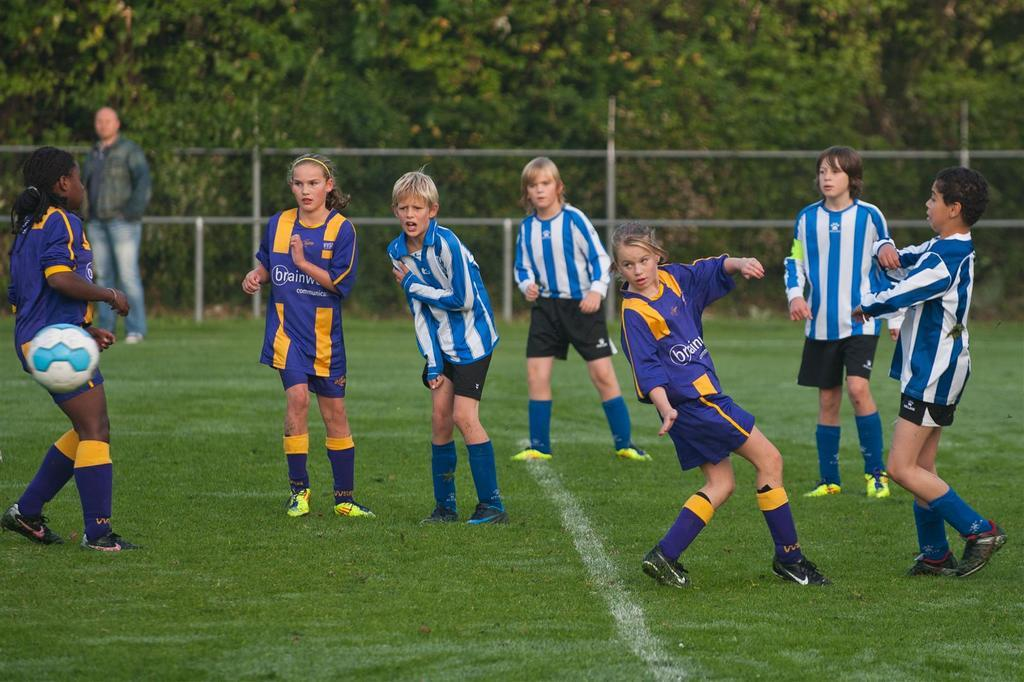What can be seen in the image? There are kids in the image. What is the ground surface like in the image? There is grass visible in the image. What is happening with the ball in the image? There is a ball in the air in the image. Can you describe the background of the image? There is a man standing, a fence, and trees in the background of the image. What type of soap is being used to clean the range in the image? There is no range or soap present in the image. How does the earthquake affect the kids in the image? There is no earthquake present in the image; the kids are playing on grass. 